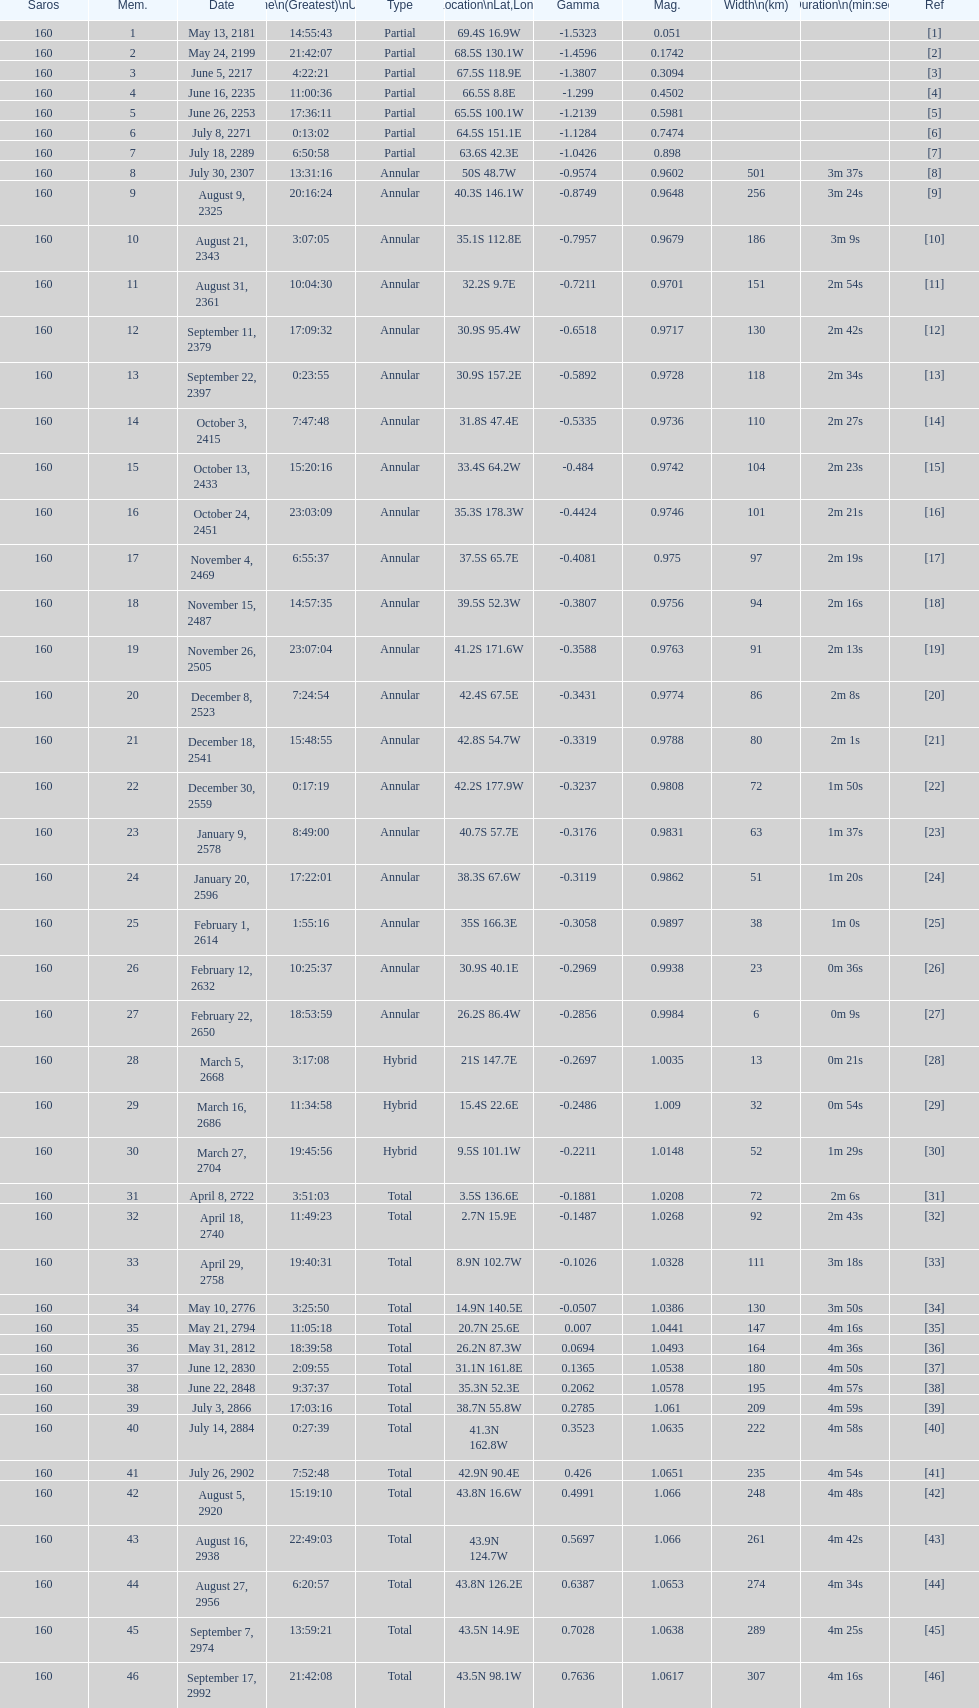How many total events will occur in all? 46. 